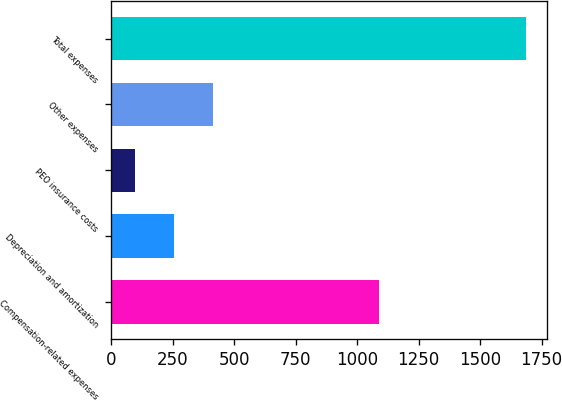Convert chart to OTSL. <chart><loc_0><loc_0><loc_500><loc_500><bar_chart><fcel>Compensation-related expenses<fcel>Depreciation and amortization<fcel>PEO insurance costs<fcel>Other expenses<fcel>Total expenses<nl><fcel>1087.1<fcel>255.18<fcel>96.2<fcel>414.16<fcel>1686<nl></chart> 